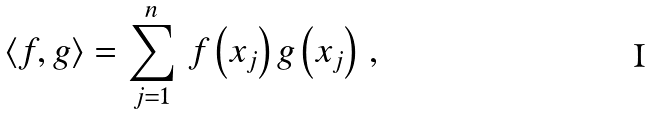Convert formula to latex. <formula><loc_0><loc_0><loc_500><loc_500>\langle f , g \rangle = \sum _ { j = 1 } ^ { n } \, f \left ( x _ { j } \right ) g \left ( x _ { j } \right ) \, ,</formula> 